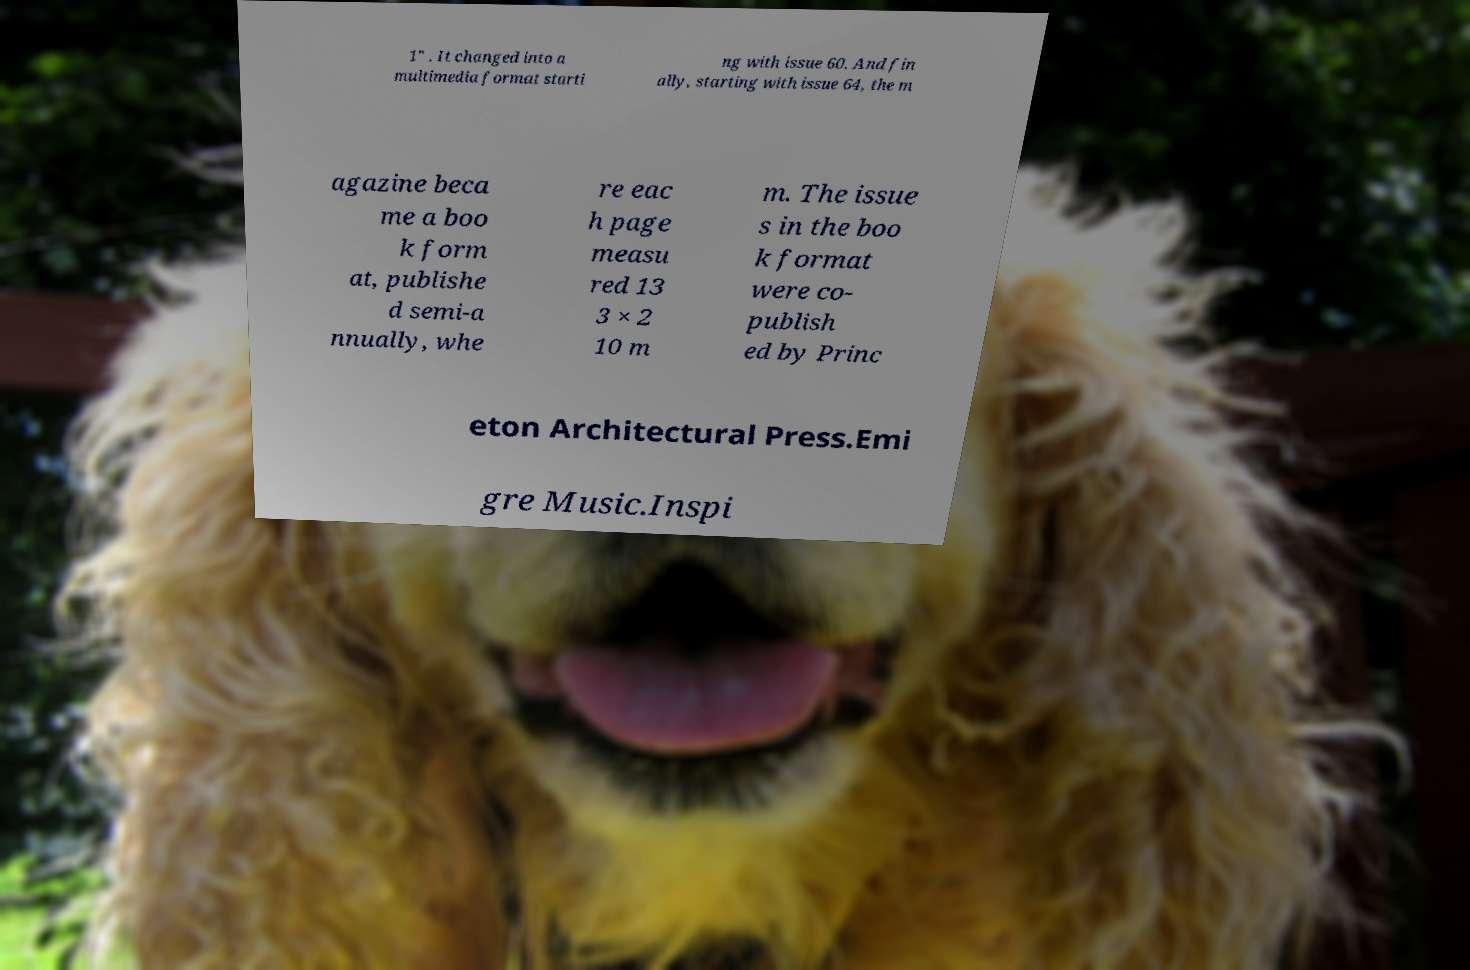For documentation purposes, I need the text within this image transcribed. Could you provide that? 1″ . It changed into a multimedia format starti ng with issue 60. And fin ally, starting with issue 64, the m agazine beca me a boo k form at, publishe d semi-a nnually, whe re eac h page measu red 13 3 × 2 10 m m. The issue s in the boo k format were co- publish ed by Princ eton Architectural Press.Emi gre Music.Inspi 